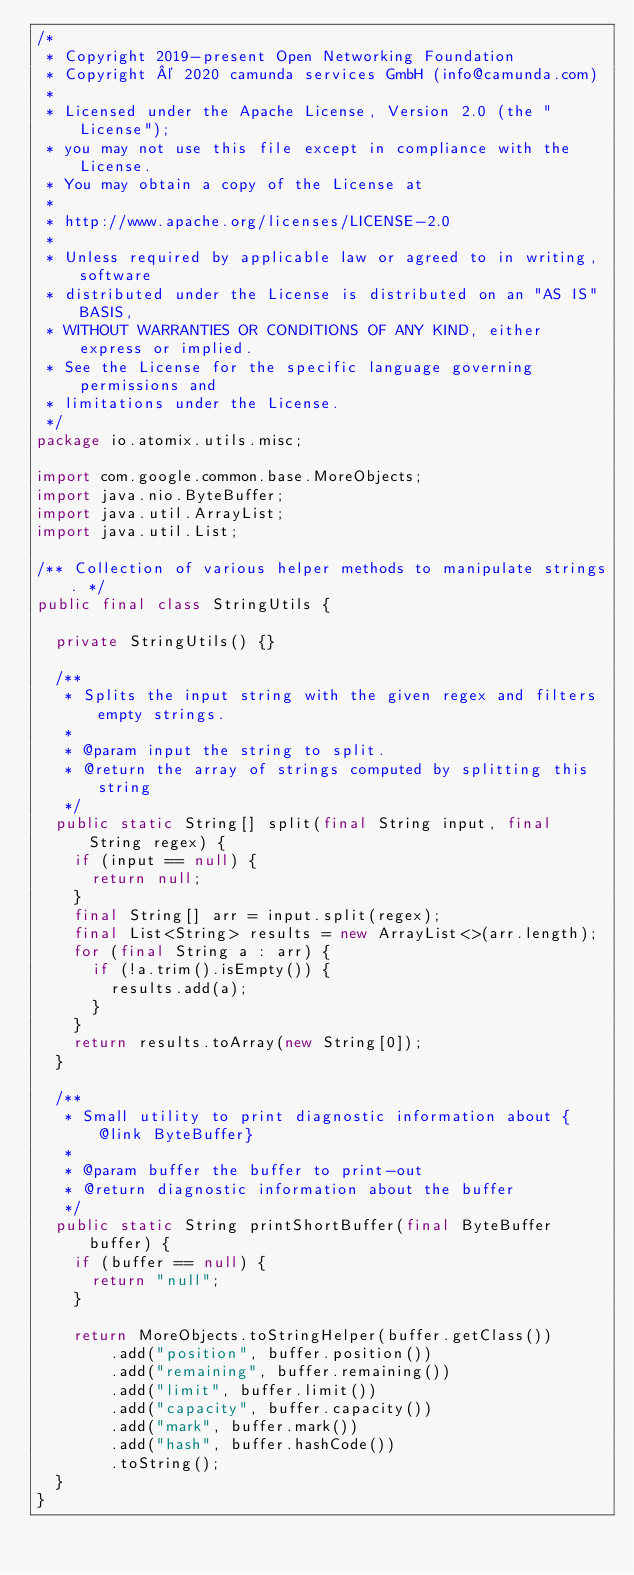Convert code to text. <code><loc_0><loc_0><loc_500><loc_500><_Java_>/*
 * Copyright 2019-present Open Networking Foundation
 * Copyright © 2020 camunda services GmbH (info@camunda.com)
 *
 * Licensed under the Apache License, Version 2.0 (the "License");
 * you may not use this file except in compliance with the License.
 * You may obtain a copy of the License at
 *
 * http://www.apache.org/licenses/LICENSE-2.0
 *
 * Unless required by applicable law or agreed to in writing, software
 * distributed under the License is distributed on an "AS IS" BASIS,
 * WITHOUT WARRANTIES OR CONDITIONS OF ANY KIND, either express or implied.
 * See the License for the specific language governing permissions and
 * limitations under the License.
 */
package io.atomix.utils.misc;

import com.google.common.base.MoreObjects;
import java.nio.ByteBuffer;
import java.util.ArrayList;
import java.util.List;

/** Collection of various helper methods to manipulate strings. */
public final class StringUtils {

  private StringUtils() {}

  /**
   * Splits the input string with the given regex and filters empty strings.
   *
   * @param input the string to split.
   * @return the array of strings computed by splitting this string
   */
  public static String[] split(final String input, final String regex) {
    if (input == null) {
      return null;
    }
    final String[] arr = input.split(regex);
    final List<String> results = new ArrayList<>(arr.length);
    for (final String a : arr) {
      if (!a.trim().isEmpty()) {
        results.add(a);
      }
    }
    return results.toArray(new String[0]);
  }

  /**
   * Small utility to print diagnostic information about {@link ByteBuffer}
   *
   * @param buffer the buffer to print-out
   * @return diagnostic information about the buffer
   */
  public static String printShortBuffer(final ByteBuffer buffer) {
    if (buffer == null) {
      return "null";
    }

    return MoreObjects.toStringHelper(buffer.getClass())
        .add("position", buffer.position())
        .add("remaining", buffer.remaining())
        .add("limit", buffer.limit())
        .add("capacity", buffer.capacity())
        .add("mark", buffer.mark())
        .add("hash", buffer.hashCode())
        .toString();
  }
}
</code> 